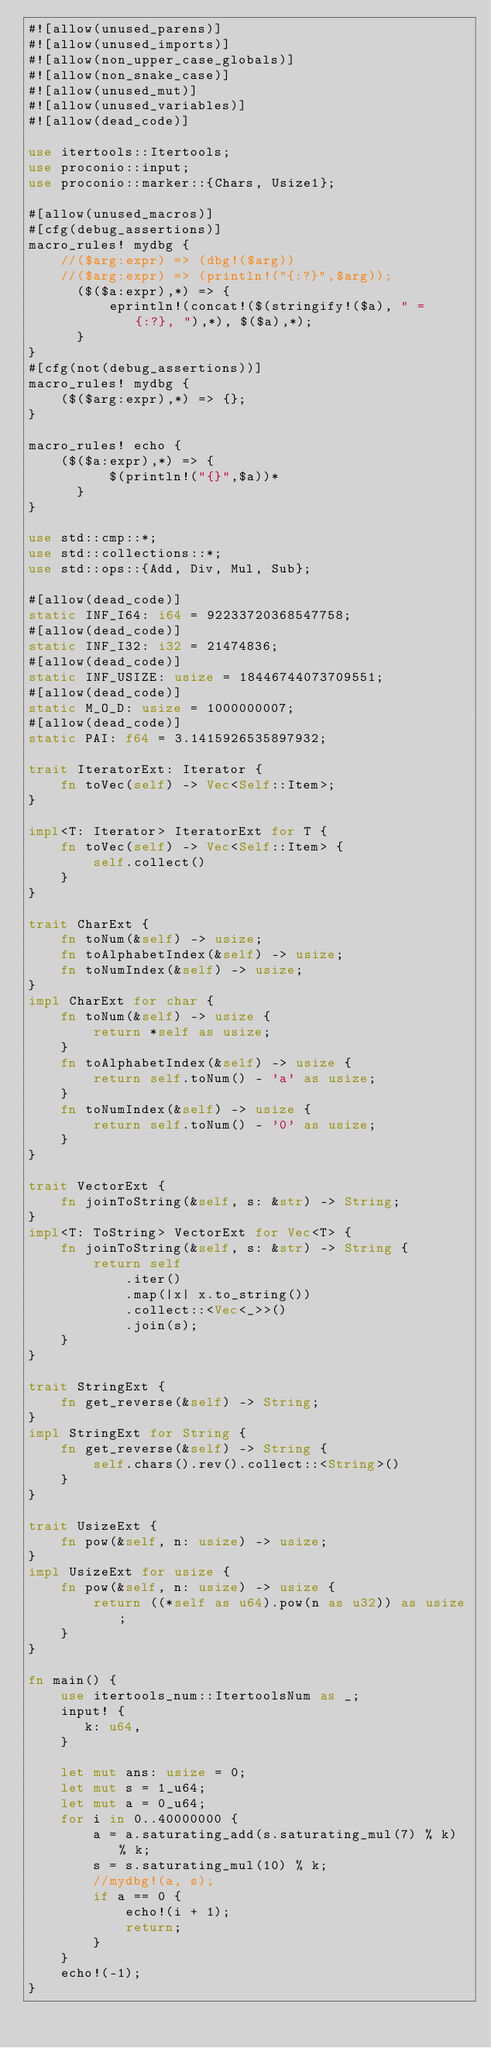Convert code to text. <code><loc_0><loc_0><loc_500><loc_500><_Rust_>#![allow(unused_parens)]
#![allow(unused_imports)]
#![allow(non_upper_case_globals)]
#![allow(non_snake_case)]
#![allow(unused_mut)]
#![allow(unused_variables)]
#![allow(dead_code)]

use itertools::Itertools;
use proconio::input;
use proconio::marker::{Chars, Usize1};

#[allow(unused_macros)]
#[cfg(debug_assertions)]
macro_rules! mydbg {
    //($arg:expr) => (dbg!($arg))
    //($arg:expr) => (println!("{:?}",$arg));
      ($($a:expr),*) => {
          eprintln!(concat!($(stringify!($a), " = {:?}, "),*), $($a),*);
      }
}
#[cfg(not(debug_assertions))]
macro_rules! mydbg {
    ($($arg:expr),*) => {};
}

macro_rules! echo {
    ($($a:expr),*) => {
          $(println!("{}",$a))*
      }
}

use std::cmp::*;
use std::collections::*;
use std::ops::{Add, Div, Mul, Sub};

#[allow(dead_code)]
static INF_I64: i64 = 92233720368547758;
#[allow(dead_code)]
static INF_I32: i32 = 21474836;
#[allow(dead_code)]
static INF_USIZE: usize = 18446744073709551;
#[allow(dead_code)]
static M_O_D: usize = 1000000007;
#[allow(dead_code)]
static PAI: f64 = 3.1415926535897932;

trait IteratorExt: Iterator {
    fn toVec(self) -> Vec<Self::Item>;
}

impl<T: Iterator> IteratorExt for T {
    fn toVec(self) -> Vec<Self::Item> {
        self.collect()
    }
}

trait CharExt {
    fn toNum(&self) -> usize;
    fn toAlphabetIndex(&self) -> usize;
    fn toNumIndex(&self) -> usize;
}
impl CharExt for char {
    fn toNum(&self) -> usize {
        return *self as usize;
    }
    fn toAlphabetIndex(&self) -> usize {
        return self.toNum() - 'a' as usize;
    }
    fn toNumIndex(&self) -> usize {
        return self.toNum() - '0' as usize;
    }
}

trait VectorExt {
    fn joinToString(&self, s: &str) -> String;
}
impl<T: ToString> VectorExt for Vec<T> {
    fn joinToString(&self, s: &str) -> String {
        return self
            .iter()
            .map(|x| x.to_string())
            .collect::<Vec<_>>()
            .join(s);
    }
}

trait StringExt {
    fn get_reverse(&self) -> String;
}
impl StringExt for String {
    fn get_reverse(&self) -> String {
        self.chars().rev().collect::<String>()
    }
}

trait UsizeExt {
    fn pow(&self, n: usize) -> usize;
}
impl UsizeExt for usize {
    fn pow(&self, n: usize) -> usize {
        return ((*self as u64).pow(n as u32)) as usize;
    }
}

fn main() {
    use itertools_num::ItertoolsNum as _;
    input! {
       k: u64,
    }

    let mut ans: usize = 0;
    let mut s = 1_u64;
    let mut a = 0_u64;
    for i in 0..40000000 {
        a = a.saturating_add(s.saturating_mul(7) % k) % k;
        s = s.saturating_mul(10) % k;
        //mydbg!(a, s);
        if a == 0 {
            echo!(i + 1);
            return;
        }
    }
    echo!(-1);
}
</code> 